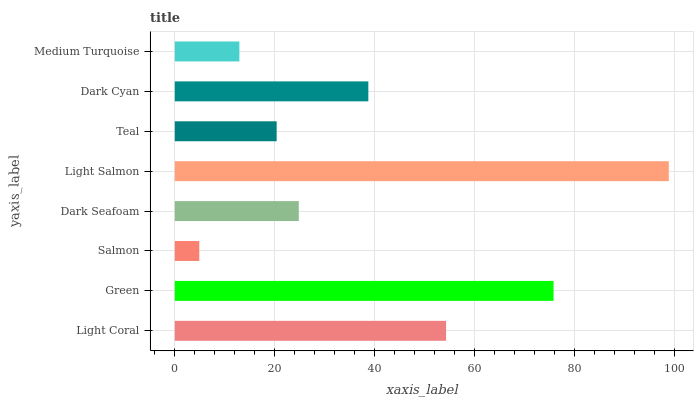Is Salmon the minimum?
Answer yes or no. Yes. Is Light Salmon the maximum?
Answer yes or no. Yes. Is Green the minimum?
Answer yes or no. No. Is Green the maximum?
Answer yes or no. No. Is Green greater than Light Coral?
Answer yes or no. Yes. Is Light Coral less than Green?
Answer yes or no. Yes. Is Light Coral greater than Green?
Answer yes or no. No. Is Green less than Light Coral?
Answer yes or no. No. Is Dark Cyan the high median?
Answer yes or no. Yes. Is Dark Seafoam the low median?
Answer yes or no. Yes. Is Teal the high median?
Answer yes or no. No. Is Light Coral the low median?
Answer yes or no. No. 